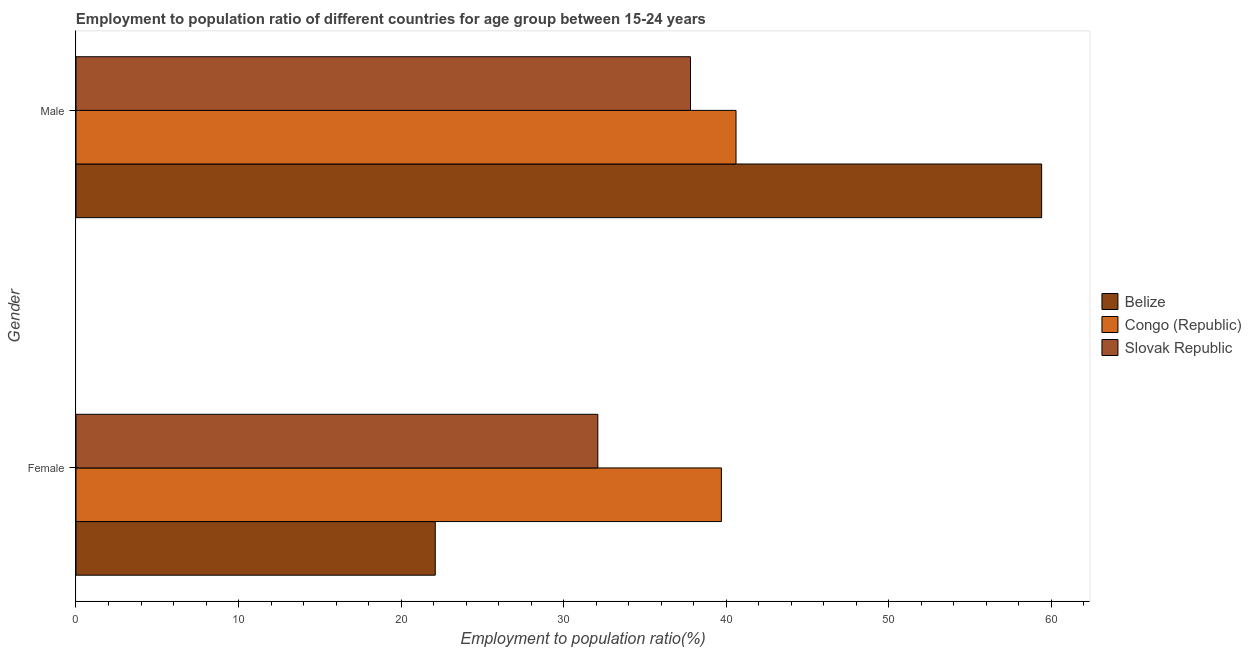How many groups of bars are there?
Give a very brief answer. 2. Are the number of bars on each tick of the Y-axis equal?
Provide a short and direct response. Yes. What is the label of the 1st group of bars from the top?
Offer a terse response. Male. What is the employment to population ratio(female) in Belize?
Your answer should be compact. 22.1. Across all countries, what is the maximum employment to population ratio(male)?
Provide a succinct answer. 59.4. Across all countries, what is the minimum employment to population ratio(female)?
Give a very brief answer. 22.1. In which country was the employment to population ratio(male) maximum?
Make the answer very short. Belize. In which country was the employment to population ratio(male) minimum?
Your answer should be very brief. Slovak Republic. What is the total employment to population ratio(male) in the graph?
Offer a very short reply. 137.8. What is the difference between the employment to population ratio(female) in Slovak Republic and that in Congo (Republic)?
Provide a short and direct response. -7.6. What is the difference between the employment to population ratio(female) in Belize and the employment to population ratio(male) in Slovak Republic?
Keep it short and to the point. -15.7. What is the average employment to population ratio(female) per country?
Provide a succinct answer. 31.3. What is the difference between the employment to population ratio(male) and employment to population ratio(female) in Belize?
Offer a very short reply. 37.3. In how many countries, is the employment to population ratio(female) greater than 2 %?
Your answer should be compact. 3. What is the ratio of the employment to population ratio(female) in Belize to that in Congo (Republic)?
Keep it short and to the point. 0.56. Is the employment to population ratio(male) in Slovak Republic less than that in Belize?
Your answer should be very brief. Yes. In how many countries, is the employment to population ratio(male) greater than the average employment to population ratio(male) taken over all countries?
Provide a short and direct response. 1. What does the 1st bar from the top in Male represents?
Ensure brevity in your answer.  Slovak Republic. What does the 1st bar from the bottom in Male represents?
Your answer should be very brief. Belize. How many bars are there?
Offer a very short reply. 6. Are all the bars in the graph horizontal?
Offer a very short reply. Yes. Are the values on the major ticks of X-axis written in scientific E-notation?
Offer a very short reply. No. Does the graph contain any zero values?
Provide a short and direct response. No. Where does the legend appear in the graph?
Provide a short and direct response. Center right. How many legend labels are there?
Your answer should be compact. 3. How are the legend labels stacked?
Ensure brevity in your answer.  Vertical. What is the title of the graph?
Make the answer very short. Employment to population ratio of different countries for age group between 15-24 years. What is the label or title of the X-axis?
Ensure brevity in your answer.  Employment to population ratio(%). What is the label or title of the Y-axis?
Provide a succinct answer. Gender. What is the Employment to population ratio(%) of Belize in Female?
Make the answer very short. 22.1. What is the Employment to population ratio(%) of Congo (Republic) in Female?
Make the answer very short. 39.7. What is the Employment to population ratio(%) in Slovak Republic in Female?
Your answer should be compact. 32.1. What is the Employment to population ratio(%) of Belize in Male?
Provide a succinct answer. 59.4. What is the Employment to population ratio(%) of Congo (Republic) in Male?
Ensure brevity in your answer.  40.6. What is the Employment to population ratio(%) in Slovak Republic in Male?
Ensure brevity in your answer.  37.8. Across all Gender, what is the maximum Employment to population ratio(%) of Belize?
Make the answer very short. 59.4. Across all Gender, what is the maximum Employment to population ratio(%) in Congo (Republic)?
Ensure brevity in your answer.  40.6. Across all Gender, what is the maximum Employment to population ratio(%) in Slovak Republic?
Give a very brief answer. 37.8. Across all Gender, what is the minimum Employment to population ratio(%) in Belize?
Make the answer very short. 22.1. Across all Gender, what is the minimum Employment to population ratio(%) in Congo (Republic)?
Your answer should be compact. 39.7. Across all Gender, what is the minimum Employment to population ratio(%) in Slovak Republic?
Make the answer very short. 32.1. What is the total Employment to population ratio(%) of Belize in the graph?
Ensure brevity in your answer.  81.5. What is the total Employment to population ratio(%) of Congo (Republic) in the graph?
Offer a very short reply. 80.3. What is the total Employment to population ratio(%) of Slovak Republic in the graph?
Keep it short and to the point. 69.9. What is the difference between the Employment to population ratio(%) of Belize in Female and that in Male?
Give a very brief answer. -37.3. What is the difference between the Employment to population ratio(%) of Belize in Female and the Employment to population ratio(%) of Congo (Republic) in Male?
Your response must be concise. -18.5. What is the difference between the Employment to population ratio(%) in Belize in Female and the Employment to population ratio(%) in Slovak Republic in Male?
Your answer should be very brief. -15.7. What is the difference between the Employment to population ratio(%) of Congo (Republic) in Female and the Employment to population ratio(%) of Slovak Republic in Male?
Your response must be concise. 1.9. What is the average Employment to population ratio(%) in Belize per Gender?
Offer a very short reply. 40.75. What is the average Employment to population ratio(%) in Congo (Republic) per Gender?
Provide a succinct answer. 40.15. What is the average Employment to population ratio(%) in Slovak Republic per Gender?
Give a very brief answer. 34.95. What is the difference between the Employment to population ratio(%) in Belize and Employment to population ratio(%) in Congo (Republic) in Female?
Your answer should be very brief. -17.6. What is the difference between the Employment to population ratio(%) of Belize and Employment to population ratio(%) of Slovak Republic in Female?
Ensure brevity in your answer.  -10. What is the difference between the Employment to population ratio(%) of Belize and Employment to population ratio(%) of Congo (Republic) in Male?
Keep it short and to the point. 18.8. What is the difference between the Employment to population ratio(%) in Belize and Employment to population ratio(%) in Slovak Republic in Male?
Provide a short and direct response. 21.6. What is the ratio of the Employment to population ratio(%) in Belize in Female to that in Male?
Give a very brief answer. 0.37. What is the ratio of the Employment to population ratio(%) in Congo (Republic) in Female to that in Male?
Make the answer very short. 0.98. What is the ratio of the Employment to population ratio(%) of Slovak Republic in Female to that in Male?
Offer a terse response. 0.85. What is the difference between the highest and the second highest Employment to population ratio(%) of Belize?
Offer a very short reply. 37.3. What is the difference between the highest and the second highest Employment to population ratio(%) in Congo (Republic)?
Ensure brevity in your answer.  0.9. What is the difference between the highest and the second highest Employment to population ratio(%) in Slovak Republic?
Provide a succinct answer. 5.7. What is the difference between the highest and the lowest Employment to population ratio(%) in Belize?
Give a very brief answer. 37.3. 